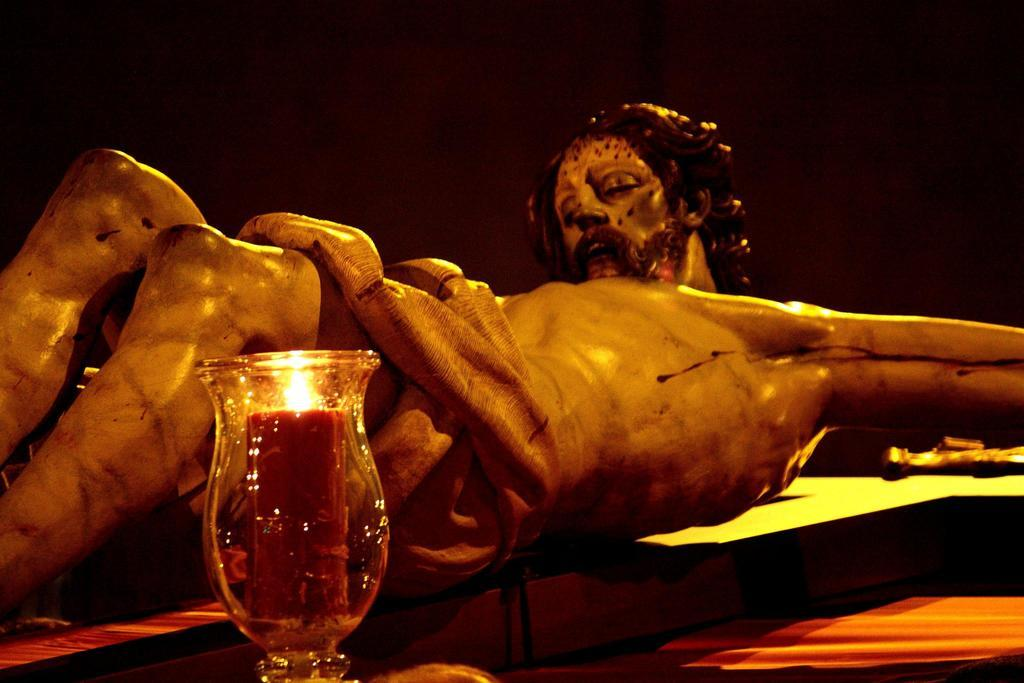What is the main subject of the image? There is a statue of Jesus Christ in the image. How is Jesus Christ depicted in the statue? The statue depicts Jesus Christ laid on the cross. What object is placed in front of the statue? There is a lamp in front of the statue. What is the profit margin of the toothpaste company mentioned in the image? There is no mention of a toothpaste company or profit margin in the image; it features a statue of Jesus Christ laid on the cross with a lamp in front of it. 